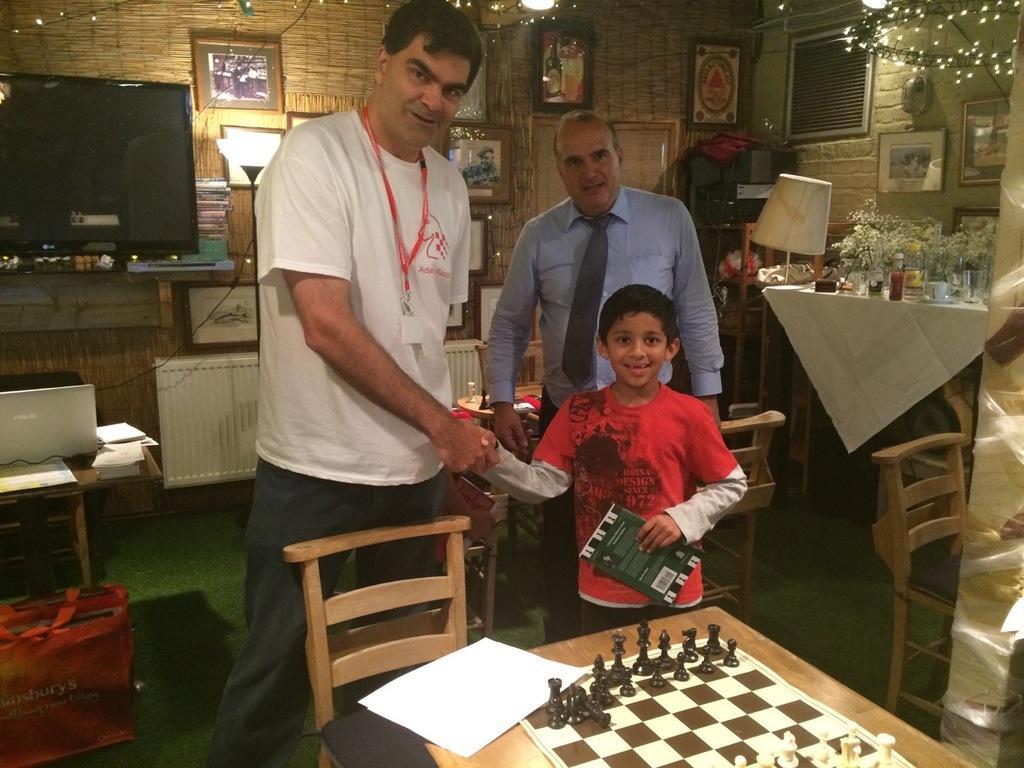Describe this image in one or two sentences. In the image there is man shaking hand to a boy, it looks like drawing room and there is an old man behind the boy and left side there is a screen and left side there is a lamp. In Front of tv screen there is a table with laptop on it and in the front there is a table with chess board and chair. 